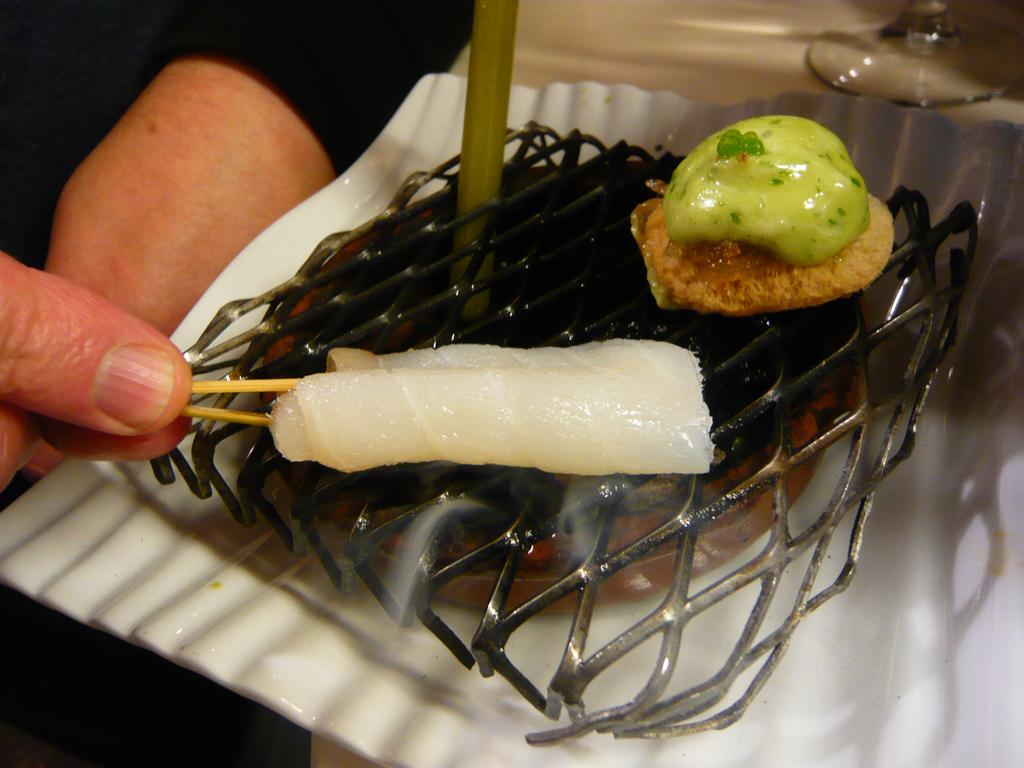What is being cooked or prepared in the image? There is food placed on the grill in the image. Can you describe any human presence in the image? There is a human hand on the left side of the image. What can be seen on the table in the image? There is a glass on the table in the top right side of the image. What type of seed is being planted with a spade in the image? There is no seed or spade present in the image; it features food on a grill and a glass on a table. 